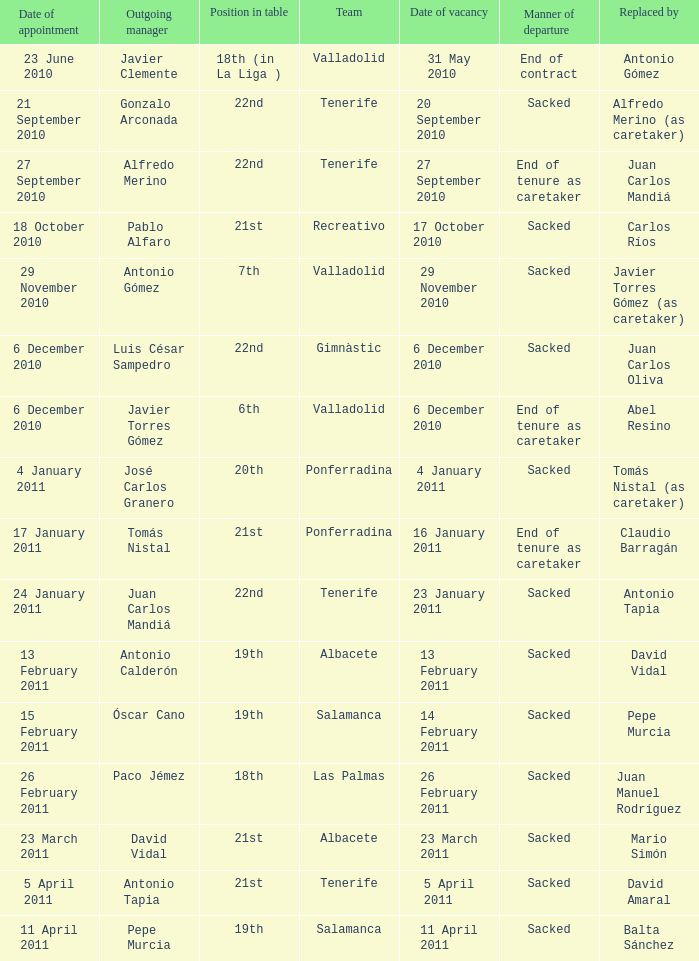What was the appointment date for outgoing manager luis césar sampedro 6 December 2010. 